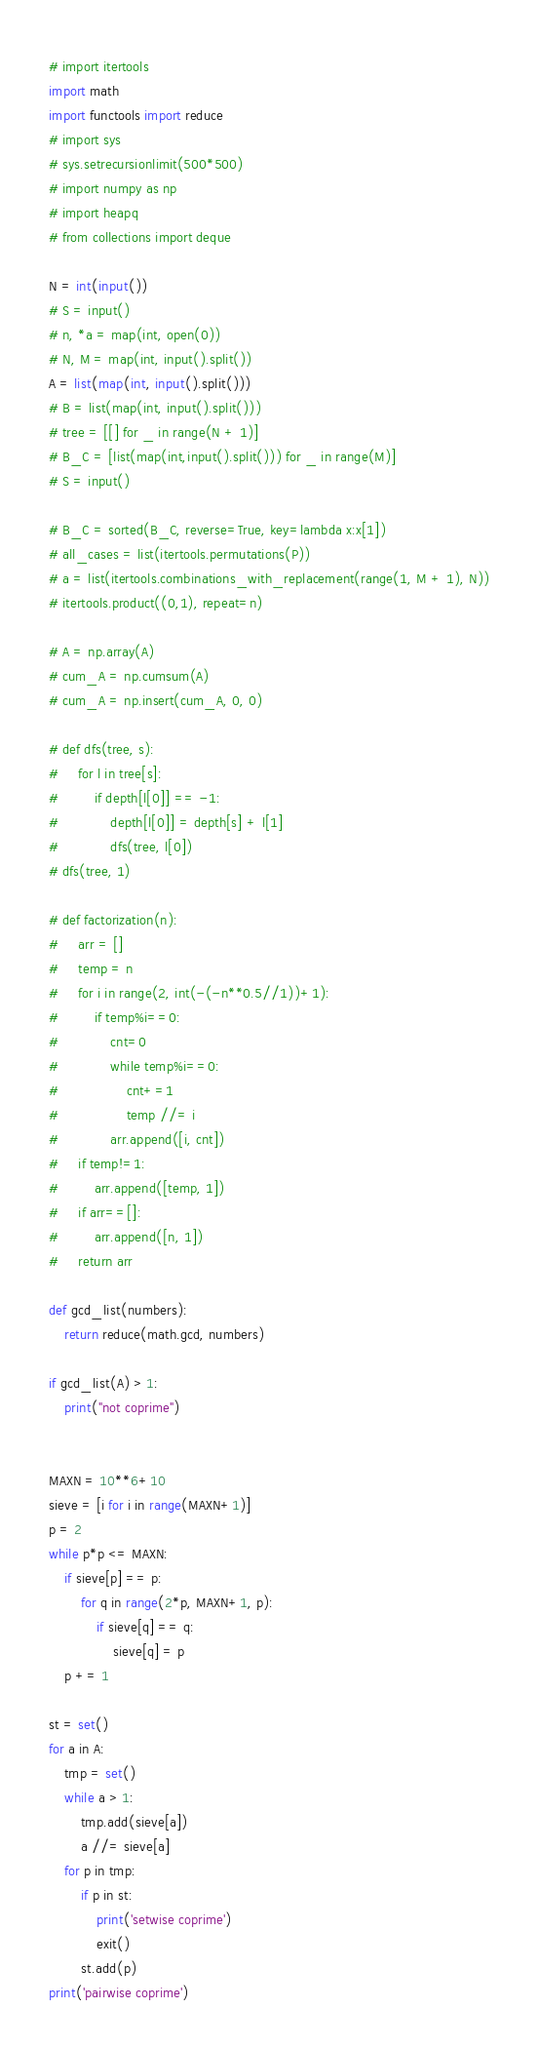Convert code to text. <code><loc_0><loc_0><loc_500><loc_500><_Python_># import itertools
import math
import functools import reduce
# import sys
# sys.setrecursionlimit(500*500)
# import numpy as np
# import heapq
# from collections import deque

N = int(input())
# S = input()
# n, *a = map(int, open(0))
# N, M = map(int, input().split())
A = list(map(int, input().split()))
# B = list(map(int, input().split()))
# tree = [[] for _ in range(N + 1)]
# B_C = [list(map(int,input().split())) for _ in range(M)]
# S = input()

# B_C = sorted(B_C, reverse=True, key=lambda x:x[1])
# all_cases = list(itertools.permutations(P))
# a = list(itertools.combinations_with_replacement(range(1, M + 1), N))
# itertools.product((0,1), repeat=n)

# A = np.array(A)
# cum_A = np.cumsum(A)
# cum_A = np.insert(cum_A, 0, 0)

# def dfs(tree, s):
#     for l in tree[s]:
#         if depth[l[0]] == -1:
#             depth[l[0]] = depth[s] + l[1]
#             dfs(tree, l[0])
# dfs(tree, 1)

# def factorization(n):
#     arr = []
#     temp = n
#     for i in range(2, int(-(-n**0.5//1))+1):
#         if temp%i==0:
#             cnt=0
#             while temp%i==0:
#                 cnt+=1
#                 temp //= i
#             arr.append([i, cnt])
#     if temp!=1:
#         arr.append([temp, 1])
#     if arr==[]:
#         arr.append([n, 1])
#     return arr

def gcd_list(numbers):
    return reduce(math.gcd, numbers)

if gcd_list(A) > 1:
    print("not coprime")


MAXN = 10**6+10
sieve = [i for i in range(MAXN+1)]
p = 2
while p*p <= MAXN:
    if sieve[p] == p:
        for q in range(2*p, MAXN+1, p):
            if sieve[q] == q:
                sieve[q] = p
    p += 1

st = set()
for a in A:
    tmp = set()
    while a > 1:
        tmp.add(sieve[a])
        a //= sieve[a]
    for p in tmp:
        if p in st:
            print('setwise coprime')
            exit()
        st.add(p)
print('pairwise coprime')
</code> 